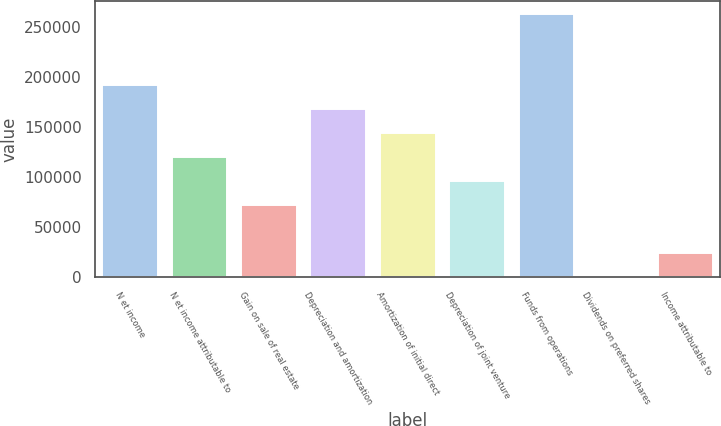Convert chart to OTSL. <chart><loc_0><loc_0><loc_500><loc_500><bar_chart><fcel>N et income<fcel>N et income attributable to<fcel>Gain on sale of real estate<fcel>Depreciation and amortization<fcel>Amortization of initial direct<fcel>Depreciation of joint venture<fcel>Funds from operations<fcel>Dividends on preferred shares<fcel>Income attributable to<nl><fcel>191803<fcel>120080<fcel>72264.1<fcel>167895<fcel>143987<fcel>96171.8<fcel>263118<fcel>541<fcel>24448.7<nl></chart> 